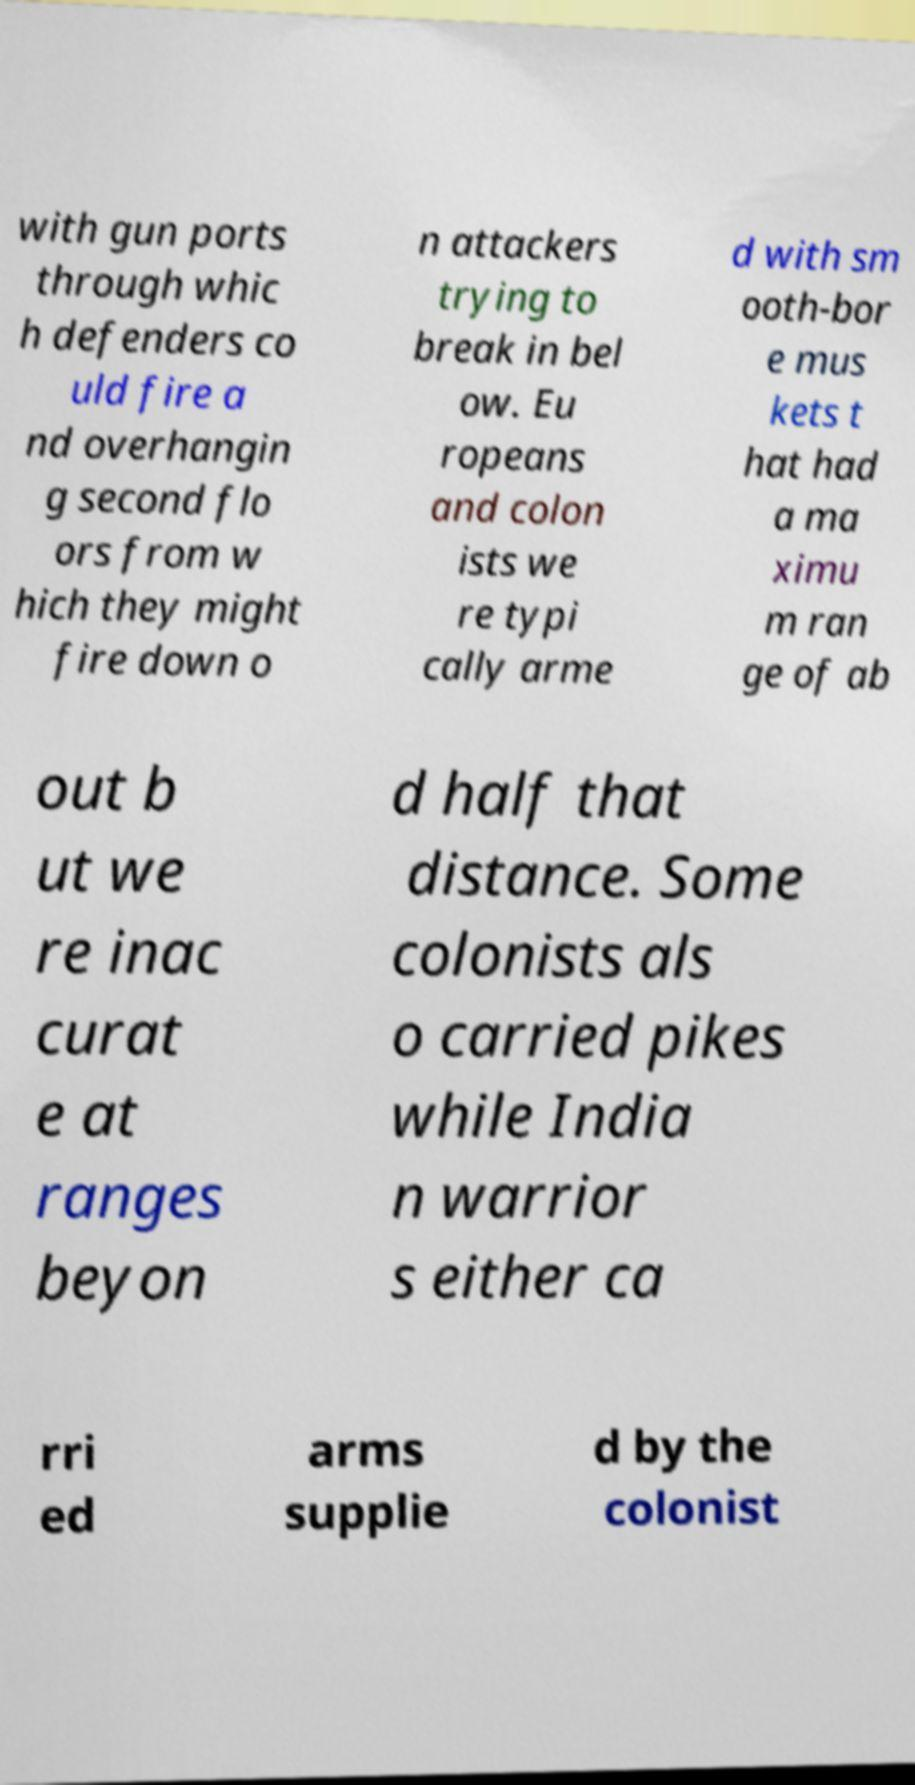Can you read and provide the text displayed in the image?This photo seems to have some interesting text. Can you extract and type it out for me? with gun ports through whic h defenders co uld fire a nd overhangin g second flo ors from w hich they might fire down o n attackers trying to break in bel ow. Eu ropeans and colon ists we re typi cally arme d with sm ooth-bor e mus kets t hat had a ma ximu m ran ge of ab out b ut we re inac curat e at ranges beyon d half that distance. Some colonists als o carried pikes while India n warrior s either ca rri ed arms supplie d by the colonist 